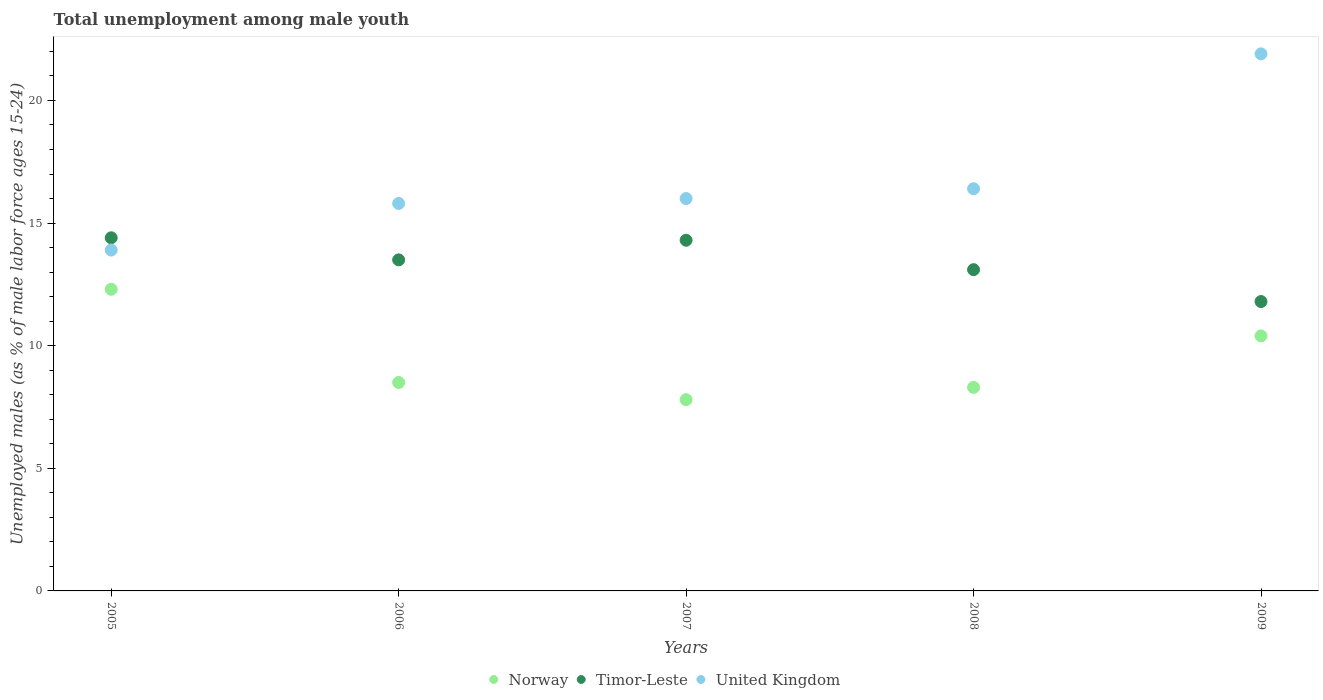What is the percentage of unemployed males in in Timor-Leste in 2005?
Offer a very short reply. 14.4. Across all years, what is the maximum percentage of unemployed males in in Norway?
Your answer should be compact. 12.3. Across all years, what is the minimum percentage of unemployed males in in Norway?
Offer a terse response. 7.8. In which year was the percentage of unemployed males in in United Kingdom maximum?
Provide a short and direct response. 2009. In which year was the percentage of unemployed males in in Norway minimum?
Give a very brief answer. 2007. What is the total percentage of unemployed males in in United Kingdom in the graph?
Ensure brevity in your answer.  84. What is the difference between the percentage of unemployed males in in Norway in 2005 and that in 2008?
Offer a terse response. 4. What is the difference between the percentage of unemployed males in in Timor-Leste in 2005 and the percentage of unemployed males in in United Kingdom in 2008?
Give a very brief answer. -2. What is the average percentage of unemployed males in in Timor-Leste per year?
Your answer should be compact. 13.42. In how many years, is the percentage of unemployed males in in Norway greater than 3 %?
Offer a very short reply. 5. What is the ratio of the percentage of unemployed males in in Norway in 2006 to that in 2009?
Keep it short and to the point. 0.82. What is the difference between the highest and the second highest percentage of unemployed males in in Timor-Leste?
Ensure brevity in your answer.  0.1. What is the difference between the highest and the lowest percentage of unemployed males in in Timor-Leste?
Give a very brief answer. 2.6. Is the sum of the percentage of unemployed males in in Norway in 2005 and 2007 greater than the maximum percentage of unemployed males in in Timor-Leste across all years?
Offer a very short reply. Yes. Is the percentage of unemployed males in in United Kingdom strictly less than the percentage of unemployed males in in Timor-Leste over the years?
Your response must be concise. No. Does the graph contain any zero values?
Your answer should be very brief. No. Where does the legend appear in the graph?
Your response must be concise. Bottom center. How many legend labels are there?
Your response must be concise. 3. What is the title of the graph?
Your answer should be compact. Total unemployment among male youth. What is the label or title of the Y-axis?
Your response must be concise. Unemployed males (as % of male labor force ages 15-24). What is the Unemployed males (as % of male labor force ages 15-24) in Norway in 2005?
Give a very brief answer. 12.3. What is the Unemployed males (as % of male labor force ages 15-24) in Timor-Leste in 2005?
Offer a very short reply. 14.4. What is the Unemployed males (as % of male labor force ages 15-24) of United Kingdom in 2005?
Provide a short and direct response. 13.9. What is the Unemployed males (as % of male labor force ages 15-24) in United Kingdom in 2006?
Ensure brevity in your answer.  15.8. What is the Unemployed males (as % of male labor force ages 15-24) of Norway in 2007?
Make the answer very short. 7.8. What is the Unemployed males (as % of male labor force ages 15-24) in Timor-Leste in 2007?
Give a very brief answer. 14.3. What is the Unemployed males (as % of male labor force ages 15-24) in Norway in 2008?
Make the answer very short. 8.3. What is the Unemployed males (as % of male labor force ages 15-24) in Timor-Leste in 2008?
Offer a terse response. 13.1. What is the Unemployed males (as % of male labor force ages 15-24) in United Kingdom in 2008?
Provide a short and direct response. 16.4. What is the Unemployed males (as % of male labor force ages 15-24) in Norway in 2009?
Give a very brief answer. 10.4. What is the Unemployed males (as % of male labor force ages 15-24) of Timor-Leste in 2009?
Offer a terse response. 11.8. What is the Unemployed males (as % of male labor force ages 15-24) of United Kingdom in 2009?
Offer a terse response. 21.9. Across all years, what is the maximum Unemployed males (as % of male labor force ages 15-24) of Norway?
Your answer should be compact. 12.3. Across all years, what is the maximum Unemployed males (as % of male labor force ages 15-24) in Timor-Leste?
Your answer should be very brief. 14.4. Across all years, what is the maximum Unemployed males (as % of male labor force ages 15-24) of United Kingdom?
Your answer should be very brief. 21.9. Across all years, what is the minimum Unemployed males (as % of male labor force ages 15-24) of Norway?
Provide a succinct answer. 7.8. Across all years, what is the minimum Unemployed males (as % of male labor force ages 15-24) in Timor-Leste?
Offer a very short reply. 11.8. Across all years, what is the minimum Unemployed males (as % of male labor force ages 15-24) in United Kingdom?
Your answer should be compact. 13.9. What is the total Unemployed males (as % of male labor force ages 15-24) of Norway in the graph?
Keep it short and to the point. 47.3. What is the total Unemployed males (as % of male labor force ages 15-24) of Timor-Leste in the graph?
Your answer should be compact. 67.1. What is the total Unemployed males (as % of male labor force ages 15-24) in United Kingdom in the graph?
Make the answer very short. 84. What is the difference between the Unemployed males (as % of male labor force ages 15-24) in Norway in 2005 and that in 2006?
Provide a short and direct response. 3.8. What is the difference between the Unemployed males (as % of male labor force ages 15-24) of Timor-Leste in 2005 and that in 2006?
Your response must be concise. 0.9. What is the difference between the Unemployed males (as % of male labor force ages 15-24) of United Kingdom in 2005 and that in 2006?
Your answer should be compact. -1.9. What is the difference between the Unemployed males (as % of male labor force ages 15-24) in Norway in 2005 and that in 2008?
Provide a succinct answer. 4. What is the difference between the Unemployed males (as % of male labor force ages 15-24) in Timor-Leste in 2005 and that in 2008?
Provide a short and direct response. 1.3. What is the difference between the Unemployed males (as % of male labor force ages 15-24) in Timor-Leste in 2005 and that in 2009?
Provide a short and direct response. 2.6. What is the difference between the Unemployed males (as % of male labor force ages 15-24) in United Kingdom in 2005 and that in 2009?
Your response must be concise. -8. What is the difference between the Unemployed males (as % of male labor force ages 15-24) in Norway in 2006 and that in 2007?
Provide a short and direct response. 0.7. What is the difference between the Unemployed males (as % of male labor force ages 15-24) of United Kingdom in 2006 and that in 2007?
Your answer should be compact. -0.2. What is the difference between the Unemployed males (as % of male labor force ages 15-24) of Norway in 2006 and that in 2008?
Offer a very short reply. 0.2. What is the difference between the Unemployed males (as % of male labor force ages 15-24) in Norway in 2006 and that in 2009?
Offer a terse response. -1.9. What is the difference between the Unemployed males (as % of male labor force ages 15-24) of Timor-Leste in 2006 and that in 2009?
Offer a terse response. 1.7. What is the difference between the Unemployed males (as % of male labor force ages 15-24) in Norway in 2007 and that in 2009?
Give a very brief answer. -2.6. What is the difference between the Unemployed males (as % of male labor force ages 15-24) of Timor-Leste in 2007 and that in 2009?
Ensure brevity in your answer.  2.5. What is the difference between the Unemployed males (as % of male labor force ages 15-24) of United Kingdom in 2007 and that in 2009?
Provide a succinct answer. -5.9. What is the difference between the Unemployed males (as % of male labor force ages 15-24) of Norway in 2008 and that in 2009?
Offer a very short reply. -2.1. What is the difference between the Unemployed males (as % of male labor force ages 15-24) in Timor-Leste in 2008 and that in 2009?
Ensure brevity in your answer.  1.3. What is the difference between the Unemployed males (as % of male labor force ages 15-24) of Norway in 2005 and the Unemployed males (as % of male labor force ages 15-24) of Timor-Leste in 2006?
Make the answer very short. -1.2. What is the difference between the Unemployed males (as % of male labor force ages 15-24) in Timor-Leste in 2005 and the Unemployed males (as % of male labor force ages 15-24) in United Kingdom in 2006?
Keep it short and to the point. -1.4. What is the difference between the Unemployed males (as % of male labor force ages 15-24) in Norway in 2005 and the Unemployed males (as % of male labor force ages 15-24) in Timor-Leste in 2007?
Offer a terse response. -2. What is the difference between the Unemployed males (as % of male labor force ages 15-24) of Norway in 2005 and the Unemployed males (as % of male labor force ages 15-24) of United Kingdom in 2007?
Make the answer very short. -3.7. What is the difference between the Unemployed males (as % of male labor force ages 15-24) of Timor-Leste in 2005 and the Unemployed males (as % of male labor force ages 15-24) of United Kingdom in 2007?
Your answer should be compact. -1.6. What is the difference between the Unemployed males (as % of male labor force ages 15-24) of Timor-Leste in 2005 and the Unemployed males (as % of male labor force ages 15-24) of United Kingdom in 2008?
Provide a short and direct response. -2. What is the difference between the Unemployed males (as % of male labor force ages 15-24) in Norway in 2005 and the Unemployed males (as % of male labor force ages 15-24) in Timor-Leste in 2009?
Your answer should be very brief. 0.5. What is the difference between the Unemployed males (as % of male labor force ages 15-24) in Norway in 2005 and the Unemployed males (as % of male labor force ages 15-24) in United Kingdom in 2009?
Keep it short and to the point. -9.6. What is the difference between the Unemployed males (as % of male labor force ages 15-24) in Timor-Leste in 2005 and the Unemployed males (as % of male labor force ages 15-24) in United Kingdom in 2009?
Keep it short and to the point. -7.5. What is the difference between the Unemployed males (as % of male labor force ages 15-24) in Norway in 2006 and the Unemployed males (as % of male labor force ages 15-24) in United Kingdom in 2007?
Make the answer very short. -7.5. What is the difference between the Unemployed males (as % of male labor force ages 15-24) in Timor-Leste in 2006 and the Unemployed males (as % of male labor force ages 15-24) in United Kingdom in 2007?
Provide a succinct answer. -2.5. What is the difference between the Unemployed males (as % of male labor force ages 15-24) in Norway in 2006 and the Unemployed males (as % of male labor force ages 15-24) in Timor-Leste in 2009?
Ensure brevity in your answer.  -3.3. What is the difference between the Unemployed males (as % of male labor force ages 15-24) of Timor-Leste in 2006 and the Unemployed males (as % of male labor force ages 15-24) of United Kingdom in 2009?
Your response must be concise. -8.4. What is the difference between the Unemployed males (as % of male labor force ages 15-24) in Norway in 2007 and the Unemployed males (as % of male labor force ages 15-24) in Timor-Leste in 2008?
Your answer should be very brief. -5.3. What is the difference between the Unemployed males (as % of male labor force ages 15-24) of Norway in 2007 and the Unemployed males (as % of male labor force ages 15-24) of United Kingdom in 2008?
Your answer should be compact. -8.6. What is the difference between the Unemployed males (as % of male labor force ages 15-24) in Norway in 2007 and the Unemployed males (as % of male labor force ages 15-24) in United Kingdom in 2009?
Make the answer very short. -14.1. What is the difference between the Unemployed males (as % of male labor force ages 15-24) in Norway in 2008 and the Unemployed males (as % of male labor force ages 15-24) in Timor-Leste in 2009?
Offer a very short reply. -3.5. What is the average Unemployed males (as % of male labor force ages 15-24) in Norway per year?
Keep it short and to the point. 9.46. What is the average Unemployed males (as % of male labor force ages 15-24) in Timor-Leste per year?
Your response must be concise. 13.42. In the year 2005, what is the difference between the Unemployed males (as % of male labor force ages 15-24) in Norway and Unemployed males (as % of male labor force ages 15-24) in Timor-Leste?
Provide a short and direct response. -2.1. In the year 2006, what is the difference between the Unemployed males (as % of male labor force ages 15-24) in Timor-Leste and Unemployed males (as % of male labor force ages 15-24) in United Kingdom?
Ensure brevity in your answer.  -2.3. In the year 2007, what is the difference between the Unemployed males (as % of male labor force ages 15-24) of Norway and Unemployed males (as % of male labor force ages 15-24) of Timor-Leste?
Your answer should be compact. -6.5. In the year 2007, what is the difference between the Unemployed males (as % of male labor force ages 15-24) of Timor-Leste and Unemployed males (as % of male labor force ages 15-24) of United Kingdom?
Keep it short and to the point. -1.7. In the year 2008, what is the difference between the Unemployed males (as % of male labor force ages 15-24) in Norway and Unemployed males (as % of male labor force ages 15-24) in Timor-Leste?
Your answer should be compact. -4.8. In the year 2008, what is the difference between the Unemployed males (as % of male labor force ages 15-24) in Norway and Unemployed males (as % of male labor force ages 15-24) in United Kingdom?
Provide a succinct answer. -8.1. In the year 2009, what is the difference between the Unemployed males (as % of male labor force ages 15-24) of Timor-Leste and Unemployed males (as % of male labor force ages 15-24) of United Kingdom?
Provide a succinct answer. -10.1. What is the ratio of the Unemployed males (as % of male labor force ages 15-24) of Norway in 2005 to that in 2006?
Keep it short and to the point. 1.45. What is the ratio of the Unemployed males (as % of male labor force ages 15-24) in Timor-Leste in 2005 to that in 2006?
Offer a very short reply. 1.07. What is the ratio of the Unemployed males (as % of male labor force ages 15-24) of United Kingdom in 2005 to that in 2006?
Provide a succinct answer. 0.88. What is the ratio of the Unemployed males (as % of male labor force ages 15-24) of Norway in 2005 to that in 2007?
Offer a terse response. 1.58. What is the ratio of the Unemployed males (as % of male labor force ages 15-24) in United Kingdom in 2005 to that in 2007?
Give a very brief answer. 0.87. What is the ratio of the Unemployed males (as % of male labor force ages 15-24) in Norway in 2005 to that in 2008?
Your answer should be very brief. 1.48. What is the ratio of the Unemployed males (as % of male labor force ages 15-24) in Timor-Leste in 2005 to that in 2008?
Keep it short and to the point. 1.1. What is the ratio of the Unemployed males (as % of male labor force ages 15-24) in United Kingdom in 2005 to that in 2008?
Your answer should be compact. 0.85. What is the ratio of the Unemployed males (as % of male labor force ages 15-24) of Norway in 2005 to that in 2009?
Keep it short and to the point. 1.18. What is the ratio of the Unemployed males (as % of male labor force ages 15-24) in Timor-Leste in 2005 to that in 2009?
Your answer should be very brief. 1.22. What is the ratio of the Unemployed males (as % of male labor force ages 15-24) in United Kingdom in 2005 to that in 2009?
Keep it short and to the point. 0.63. What is the ratio of the Unemployed males (as % of male labor force ages 15-24) of Norway in 2006 to that in 2007?
Keep it short and to the point. 1.09. What is the ratio of the Unemployed males (as % of male labor force ages 15-24) in Timor-Leste in 2006 to that in 2007?
Keep it short and to the point. 0.94. What is the ratio of the Unemployed males (as % of male labor force ages 15-24) of United Kingdom in 2006 to that in 2007?
Provide a short and direct response. 0.99. What is the ratio of the Unemployed males (as % of male labor force ages 15-24) in Norway in 2006 to that in 2008?
Your answer should be compact. 1.02. What is the ratio of the Unemployed males (as % of male labor force ages 15-24) in Timor-Leste in 2006 to that in 2008?
Your answer should be very brief. 1.03. What is the ratio of the Unemployed males (as % of male labor force ages 15-24) of United Kingdom in 2006 to that in 2008?
Offer a very short reply. 0.96. What is the ratio of the Unemployed males (as % of male labor force ages 15-24) in Norway in 2006 to that in 2009?
Make the answer very short. 0.82. What is the ratio of the Unemployed males (as % of male labor force ages 15-24) of Timor-Leste in 2006 to that in 2009?
Provide a short and direct response. 1.14. What is the ratio of the Unemployed males (as % of male labor force ages 15-24) of United Kingdom in 2006 to that in 2009?
Your answer should be very brief. 0.72. What is the ratio of the Unemployed males (as % of male labor force ages 15-24) in Norway in 2007 to that in 2008?
Keep it short and to the point. 0.94. What is the ratio of the Unemployed males (as % of male labor force ages 15-24) in Timor-Leste in 2007 to that in 2008?
Offer a terse response. 1.09. What is the ratio of the Unemployed males (as % of male labor force ages 15-24) of United Kingdom in 2007 to that in 2008?
Offer a very short reply. 0.98. What is the ratio of the Unemployed males (as % of male labor force ages 15-24) of Timor-Leste in 2007 to that in 2009?
Give a very brief answer. 1.21. What is the ratio of the Unemployed males (as % of male labor force ages 15-24) of United Kingdom in 2007 to that in 2009?
Ensure brevity in your answer.  0.73. What is the ratio of the Unemployed males (as % of male labor force ages 15-24) in Norway in 2008 to that in 2009?
Your answer should be very brief. 0.8. What is the ratio of the Unemployed males (as % of male labor force ages 15-24) in Timor-Leste in 2008 to that in 2009?
Keep it short and to the point. 1.11. What is the ratio of the Unemployed males (as % of male labor force ages 15-24) in United Kingdom in 2008 to that in 2009?
Your response must be concise. 0.75. What is the difference between the highest and the second highest Unemployed males (as % of male labor force ages 15-24) of Norway?
Provide a succinct answer. 1.9. What is the difference between the highest and the second highest Unemployed males (as % of male labor force ages 15-24) of United Kingdom?
Give a very brief answer. 5.5. What is the difference between the highest and the lowest Unemployed males (as % of male labor force ages 15-24) of Timor-Leste?
Your answer should be very brief. 2.6. 